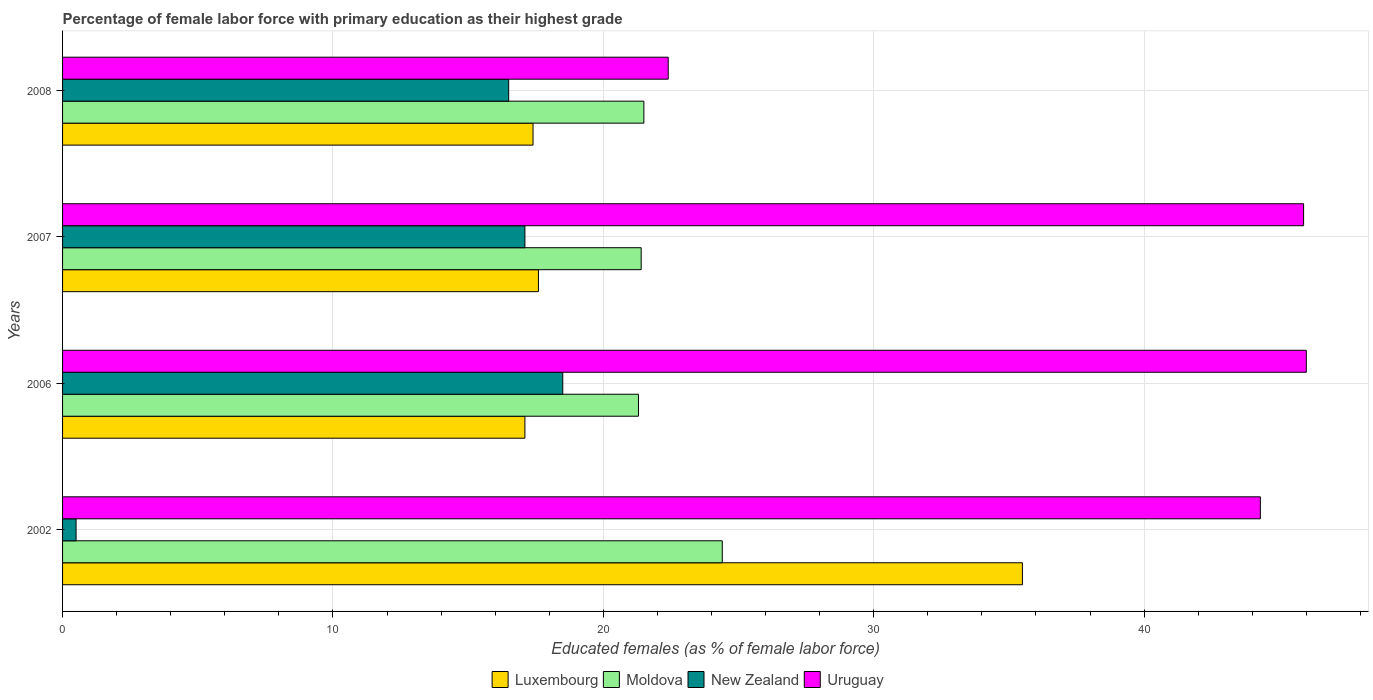What is the label of the 1st group of bars from the top?
Your answer should be very brief. 2008. What is the percentage of female labor force with primary education in Luxembourg in 2002?
Your answer should be compact. 35.5. Across all years, what is the maximum percentage of female labor force with primary education in New Zealand?
Your answer should be compact. 18.5. Across all years, what is the minimum percentage of female labor force with primary education in Uruguay?
Provide a short and direct response. 22.4. In which year was the percentage of female labor force with primary education in Moldova maximum?
Keep it short and to the point. 2002. In which year was the percentage of female labor force with primary education in Uruguay minimum?
Make the answer very short. 2008. What is the total percentage of female labor force with primary education in Moldova in the graph?
Make the answer very short. 88.6. What is the difference between the percentage of female labor force with primary education in Uruguay in 2002 and that in 2006?
Ensure brevity in your answer.  -1.7. What is the difference between the percentage of female labor force with primary education in Uruguay in 2006 and the percentage of female labor force with primary education in Luxembourg in 2008?
Your answer should be very brief. 28.6. What is the average percentage of female labor force with primary education in Moldova per year?
Your answer should be very brief. 22.15. In the year 2008, what is the difference between the percentage of female labor force with primary education in Luxembourg and percentage of female labor force with primary education in Uruguay?
Offer a very short reply. -5. In how many years, is the percentage of female labor force with primary education in Luxembourg greater than 38 %?
Offer a terse response. 0. What is the ratio of the percentage of female labor force with primary education in Luxembourg in 2006 to that in 2007?
Your response must be concise. 0.97. Is the percentage of female labor force with primary education in Moldova in 2002 less than that in 2006?
Provide a succinct answer. No. What is the difference between the highest and the second highest percentage of female labor force with primary education in Luxembourg?
Give a very brief answer. 17.9. What is the difference between the highest and the lowest percentage of female labor force with primary education in New Zealand?
Keep it short and to the point. 18. In how many years, is the percentage of female labor force with primary education in Moldova greater than the average percentage of female labor force with primary education in Moldova taken over all years?
Keep it short and to the point. 1. What does the 1st bar from the top in 2008 represents?
Your answer should be very brief. Uruguay. What does the 2nd bar from the bottom in 2002 represents?
Offer a terse response. Moldova. Is it the case that in every year, the sum of the percentage of female labor force with primary education in Uruguay and percentage of female labor force with primary education in New Zealand is greater than the percentage of female labor force with primary education in Moldova?
Offer a terse response. Yes. How many years are there in the graph?
Offer a terse response. 4. What is the difference between two consecutive major ticks on the X-axis?
Your answer should be very brief. 10. Does the graph contain any zero values?
Your answer should be compact. No. Does the graph contain grids?
Your answer should be very brief. Yes. How are the legend labels stacked?
Your answer should be very brief. Horizontal. What is the title of the graph?
Ensure brevity in your answer.  Percentage of female labor force with primary education as their highest grade. What is the label or title of the X-axis?
Offer a very short reply. Educated females (as % of female labor force). What is the label or title of the Y-axis?
Provide a succinct answer. Years. What is the Educated females (as % of female labor force) in Luxembourg in 2002?
Provide a succinct answer. 35.5. What is the Educated females (as % of female labor force) in Moldova in 2002?
Your answer should be very brief. 24.4. What is the Educated females (as % of female labor force) in New Zealand in 2002?
Offer a terse response. 0.5. What is the Educated females (as % of female labor force) in Uruguay in 2002?
Keep it short and to the point. 44.3. What is the Educated females (as % of female labor force) of Luxembourg in 2006?
Provide a short and direct response. 17.1. What is the Educated females (as % of female labor force) in Moldova in 2006?
Give a very brief answer. 21.3. What is the Educated females (as % of female labor force) of Uruguay in 2006?
Provide a short and direct response. 46. What is the Educated females (as % of female labor force) of Luxembourg in 2007?
Offer a very short reply. 17.6. What is the Educated females (as % of female labor force) of Moldova in 2007?
Provide a short and direct response. 21.4. What is the Educated females (as % of female labor force) of New Zealand in 2007?
Your answer should be very brief. 17.1. What is the Educated females (as % of female labor force) in Uruguay in 2007?
Make the answer very short. 45.9. What is the Educated females (as % of female labor force) in Luxembourg in 2008?
Keep it short and to the point. 17.4. What is the Educated females (as % of female labor force) of Uruguay in 2008?
Make the answer very short. 22.4. Across all years, what is the maximum Educated females (as % of female labor force) in Luxembourg?
Provide a short and direct response. 35.5. Across all years, what is the maximum Educated females (as % of female labor force) in Moldova?
Provide a short and direct response. 24.4. Across all years, what is the minimum Educated females (as % of female labor force) in Luxembourg?
Offer a very short reply. 17.1. Across all years, what is the minimum Educated females (as % of female labor force) in Moldova?
Offer a terse response. 21.3. Across all years, what is the minimum Educated females (as % of female labor force) in New Zealand?
Offer a terse response. 0.5. Across all years, what is the minimum Educated females (as % of female labor force) in Uruguay?
Keep it short and to the point. 22.4. What is the total Educated females (as % of female labor force) in Luxembourg in the graph?
Give a very brief answer. 87.6. What is the total Educated females (as % of female labor force) of Moldova in the graph?
Provide a short and direct response. 88.6. What is the total Educated females (as % of female labor force) in New Zealand in the graph?
Keep it short and to the point. 52.6. What is the total Educated females (as % of female labor force) in Uruguay in the graph?
Offer a very short reply. 158.6. What is the difference between the Educated females (as % of female labor force) in Luxembourg in 2002 and that in 2006?
Your answer should be very brief. 18.4. What is the difference between the Educated females (as % of female labor force) in Moldova in 2002 and that in 2006?
Your answer should be compact. 3.1. What is the difference between the Educated females (as % of female labor force) of Uruguay in 2002 and that in 2006?
Give a very brief answer. -1.7. What is the difference between the Educated females (as % of female labor force) in New Zealand in 2002 and that in 2007?
Provide a short and direct response. -16.6. What is the difference between the Educated females (as % of female labor force) of New Zealand in 2002 and that in 2008?
Your response must be concise. -16. What is the difference between the Educated females (as % of female labor force) in Uruguay in 2002 and that in 2008?
Provide a succinct answer. 21.9. What is the difference between the Educated females (as % of female labor force) in Luxembourg in 2006 and that in 2007?
Offer a very short reply. -0.5. What is the difference between the Educated females (as % of female labor force) in Moldova in 2006 and that in 2007?
Make the answer very short. -0.1. What is the difference between the Educated females (as % of female labor force) of Moldova in 2006 and that in 2008?
Your response must be concise. -0.2. What is the difference between the Educated females (as % of female labor force) of New Zealand in 2006 and that in 2008?
Your answer should be very brief. 2. What is the difference between the Educated females (as % of female labor force) of Uruguay in 2006 and that in 2008?
Offer a very short reply. 23.6. What is the difference between the Educated females (as % of female labor force) of Luxembourg in 2007 and that in 2008?
Offer a very short reply. 0.2. What is the difference between the Educated females (as % of female labor force) in Uruguay in 2007 and that in 2008?
Make the answer very short. 23.5. What is the difference between the Educated females (as % of female labor force) in Moldova in 2002 and the Educated females (as % of female labor force) in Uruguay in 2006?
Offer a terse response. -21.6. What is the difference between the Educated females (as % of female labor force) in New Zealand in 2002 and the Educated females (as % of female labor force) in Uruguay in 2006?
Your response must be concise. -45.5. What is the difference between the Educated females (as % of female labor force) of Moldova in 2002 and the Educated females (as % of female labor force) of New Zealand in 2007?
Make the answer very short. 7.3. What is the difference between the Educated females (as % of female labor force) in Moldova in 2002 and the Educated females (as % of female labor force) in Uruguay in 2007?
Ensure brevity in your answer.  -21.5. What is the difference between the Educated females (as % of female labor force) in New Zealand in 2002 and the Educated females (as % of female labor force) in Uruguay in 2007?
Provide a short and direct response. -45.4. What is the difference between the Educated females (as % of female labor force) in Luxembourg in 2002 and the Educated females (as % of female labor force) in New Zealand in 2008?
Your answer should be very brief. 19. What is the difference between the Educated females (as % of female labor force) of Moldova in 2002 and the Educated females (as % of female labor force) of Uruguay in 2008?
Your answer should be compact. 2. What is the difference between the Educated females (as % of female labor force) in New Zealand in 2002 and the Educated females (as % of female labor force) in Uruguay in 2008?
Keep it short and to the point. -21.9. What is the difference between the Educated females (as % of female labor force) in Luxembourg in 2006 and the Educated females (as % of female labor force) in Moldova in 2007?
Your response must be concise. -4.3. What is the difference between the Educated females (as % of female labor force) in Luxembourg in 2006 and the Educated females (as % of female labor force) in Uruguay in 2007?
Offer a very short reply. -28.8. What is the difference between the Educated females (as % of female labor force) of Moldova in 2006 and the Educated females (as % of female labor force) of New Zealand in 2007?
Offer a terse response. 4.2. What is the difference between the Educated females (as % of female labor force) in Moldova in 2006 and the Educated females (as % of female labor force) in Uruguay in 2007?
Your answer should be compact. -24.6. What is the difference between the Educated females (as % of female labor force) in New Zealand in 2006 and the Educated females (as % of female labor force) in Uruguay in 2007?
Offer a terse response. -27.4. What is the difference between the Educated females (as % of female labor force) of Luxembourg in 2006 and the Educated females (as % of female labor force) of Moldova in 2008?
Your response must be concise. -4.4. What is the difference between the Educated females (as % of female labor force) of Luxembourg in 2006 and the Educated females (as % of female labor force) of Uruguay in 2008?
Give a very brief answer. -5.3. What is the difference between the Educated females (as % of female labor force) in Moldova in 2006 and the Educated females (as % of female labor force) in New Zealand in 2008?
Provide a short and direct response. 4.8. What is the difference between the Educated females (as % of female labor force) of Moldova in 2006 and the Educated females (as % of female labor force) of Uruguay in 2008?
Provide a short and direct response. -1.1. What is the difference between the Educated females (as % of female labor force) of Luxembourg in 2007 and the Educated females (as % of female labor force) of Moldova in 2008?
Make the answer very short. -3.9. What is the difference between the Educated females (as % of female labor force) of Luxembourg in 2007 and the Educated females (as % of female labor force) of New Zealand in 2008?
Offer a terse response. 1.1. What is the difference between the Educated females (as % of female labor force) of Luxembourg in 2007 and the Educated females (as % of female labor force) of Uruguay in 2008?
Keep it short and to the point. -4.8. What is the difference between the Educated females (as % of female labor force) in Moldova in 2007 and the Educated females (as % of female labor force) in New Zealand in 2008?
Provide a succinct answer. 4.9. What is the average Educated females (as % of female labor force) in Luxembourg per year?
Ensure brevity in your answer.  21.9. What is the average Educated females (as % of female labor force) in Moldova per year?
Offer a very short reply. 22.15. What is the average Educated females (as % of female labor force) in New Zealand per year?
Your answer should be compact. 13.15. What is the average Educated females (as % of female labor force) of Uruguay per year?
Your response must be concise. 39.65. In the year 2002, what is the difference between the Educated females (as % of female labor force) in Moldova and Educated females (as % of female labor force) in New Zealand?
Your answer should be very brief. 23.9. In the year 2002, what is the difference between the Educated females (as % of female labor force) in Moldova and Educated females (as % of female labor force) in Uruguay?
Your answer should be very brief. -19.9. In the year 2002, what is the difference between the Educated females (as % of female labor force) of New Zealand and Educated females (as % of female labor force) of Uruguay?
Ensure brevity in your answer.  -43.8. In the year 2006, what is the difference between the Educated females (as % of female labor force) of Luxembourg and Educated females (as % of female labor force) of New Zealand?
Your answer should be compact. -1.4. In the year 2006, what is the difference between the Educated females (as % of female labor force) in Luxembourg and Educated females (as % of female labor force) in Uruguay?
Offer a terse response. -28.9. In the year 2006, what is the difference between the Educated females (as % of female labor force) in Moldova and Educated females (as % of female labor force) in New Zealand?
Keep it short and to the point. 2.8. In the year 2006, what is the difference between the Educated females (as % of female labor force) in Moldova and Educated females (as % of female labor force) in Uruguay?
Keep it short and to the point. -24.7. In the year 2006, what is the difference between the Educated females (as % of female labor force) of New Zealand and Educated females (as % of female labor force) of Uruguay?
Your answer should be very brief. -27.5. In the year 2007, what is the difference between the Educated females (as % of female labor force) in Luxembourg and Educated females (as % of female labor force) in New Zealand?
Offer a terse response. 0.5. In the year 2007, what is the difference between the Educated females (as % of female labor force) in Luxembourg and Educated females (as % of female labor force) in Uruguay?
Provide a succinct answer. -28.3. In the year 2007, what is the difference between the Educated females (as % of female labor force) in Moldova and Educated females (as % of female labor force) in Uruguay?
Give a very brief answer. -24.5. In the year 2007, what is the difference between the Educated females (as % of female labor force) in New Zealand and Educated females (as % of female labor force) in Uruguay?
Offer a very short reply. -28.8. In the year 2008, what is the difference between the Educated females (as % of female labor force) in Luxembourg and Educated females (as % of female labor force) in Moldova?
Offer a terse response. -4.1. In the year 2008, what is the difference between the Educated females (as % of female labor force) in Moldova and Educated females (as % of female labor force) in New Zealand?
Make the answer very short. 5. In the year 2008, what is the difference between the Educated females (as % of female labor force) in Moldova and Educated females (as % of female labor force) in Uruguay?
Make the answer very short. -0.9. What is the ratio of the Educated females (as % of female labor force) in Luxembourg in 2002 to that in 2006?
Give a very brief answer. 2.08. What is the ratio of the Educated females (as % of female labor force) in Moldova in 2002 to that in 2006?
Offer a terse response. 1.15. What is the ratio of the Educated females (as % of female labor force) in New Zealand in 2002 to that in 2006?
Keep it short and to the point. 0.03. What is the ratio of the Educated females (as % of female labor force) of Uruguay in 2002 to that in 2006?
Give a very brief answer. 0.96. What is the ratio of the Educated females (as % of female labor force) of Luxembourg in 2002 to that in 2007?
Keep it short and to the point. 2.02. What is the ratio of the Educated females (as % of female labor force) in Moldova in 2002 to that in 2007?
Offer a very short reply. 1.14. What is the ratio of the Educated females (as % of female labor force) in New Zealand in 2002 to that in 2007?
Provide a succinct answer. 0.03. What is the ratio of the Educated females (as % of female labor force) in Uruguay in 2002 to that in 2007?
Provide a succinct answer. 0.97. What is the ratio of the Educated females (as % of female labor force) of Luxembourg in 2002 to that in 2008?
Ensure brevity in your answer.  2.04. What is the ratio of the Educated females (as % of female labor force) of Moldova in 2002 to that in 2008?
Make the answer very short. 1.13. What is the ratio of the Educated females (as % of female labor force) of New Zealand in 2002 to that in 2008?
Make the answer very short. 0.03. What is the ratio of the Educated females (as % of female labor force) in Uruguay in 2002 to that in 2008?
Give a very brief answer. 1.98. What is the ratio of the Educated females (as % of female labor force) in Luxembourg in 2006 to that in 2007?
Your response must be concise. 0.97. What is the ratio of the Educated females (as % of female labor force) in Moldova in 2006 to that in 2007?
Give a very brief answer. 1. What is the ratio of the Educated females (as % of female labor force) in New Zealand in 2006 to that in 2007?
Make the answer very short. 1.08. What is the ratio of the Educated females (as % of female labor force) in Uruguay in 2006 to that in 2007?
Ensure brevity in your answer.  1. What is the ratio of the Educated females (as % of female labor force) of Luxembourg in 2006 to that in 2008?
Ensure brevity in your answer.  0.98. What is the ratio of the Educated females (as % of female labor force) of New Zealand in 2006 to that in 2008?
Your response must be concise. 1.12. What is the ratio of the Educated females (as % of female labor force) in Uruguay in 2006 to that in 2008?
Ensure brevity in your answer.  2.05. What is the ratio of the Educated females (as % of female labor force) in Luxembourg in 2007 to that in 2008?
Ensure brevity in your answer.  1.01. What is the ratio of the Educated females (as % of female labor force) of New Zealand in 2007 to that in 2008?
Your answer should be very brief. 1.04. What is the ratio of the Educated females (as % of female labor force) in Uruguay in 2007 to that in 2008?
Keep it short and to the point. 2.05. What is the difference between the highest and the second highest Educated females (as % of female labor force) of Luxembourg?
Provide a short and direct response. 17.9. What is the difference between the highest and the second highest Educated females (as % of female labor force) in Moldova?
Provide a succinct answer. 2.9. What is the difference between the highest and the second highest Educated females (as % of female labor force) of New Zealand?
Make the answer very short. 1.4. What is the difference between the highest and the lowest Educated females (as % of female labor force) of Luxembourg?
Provide a short and direct response. 18.4. What is the difference between the highest and the lowest Educated females (as % of female labor force) of Moldova?
Make the answer very short. 3.1. What is the difference between the highest and the lowest Educated females (as % of female labor force) of Uruguay?
Keep it short and to the point. 23.6. 